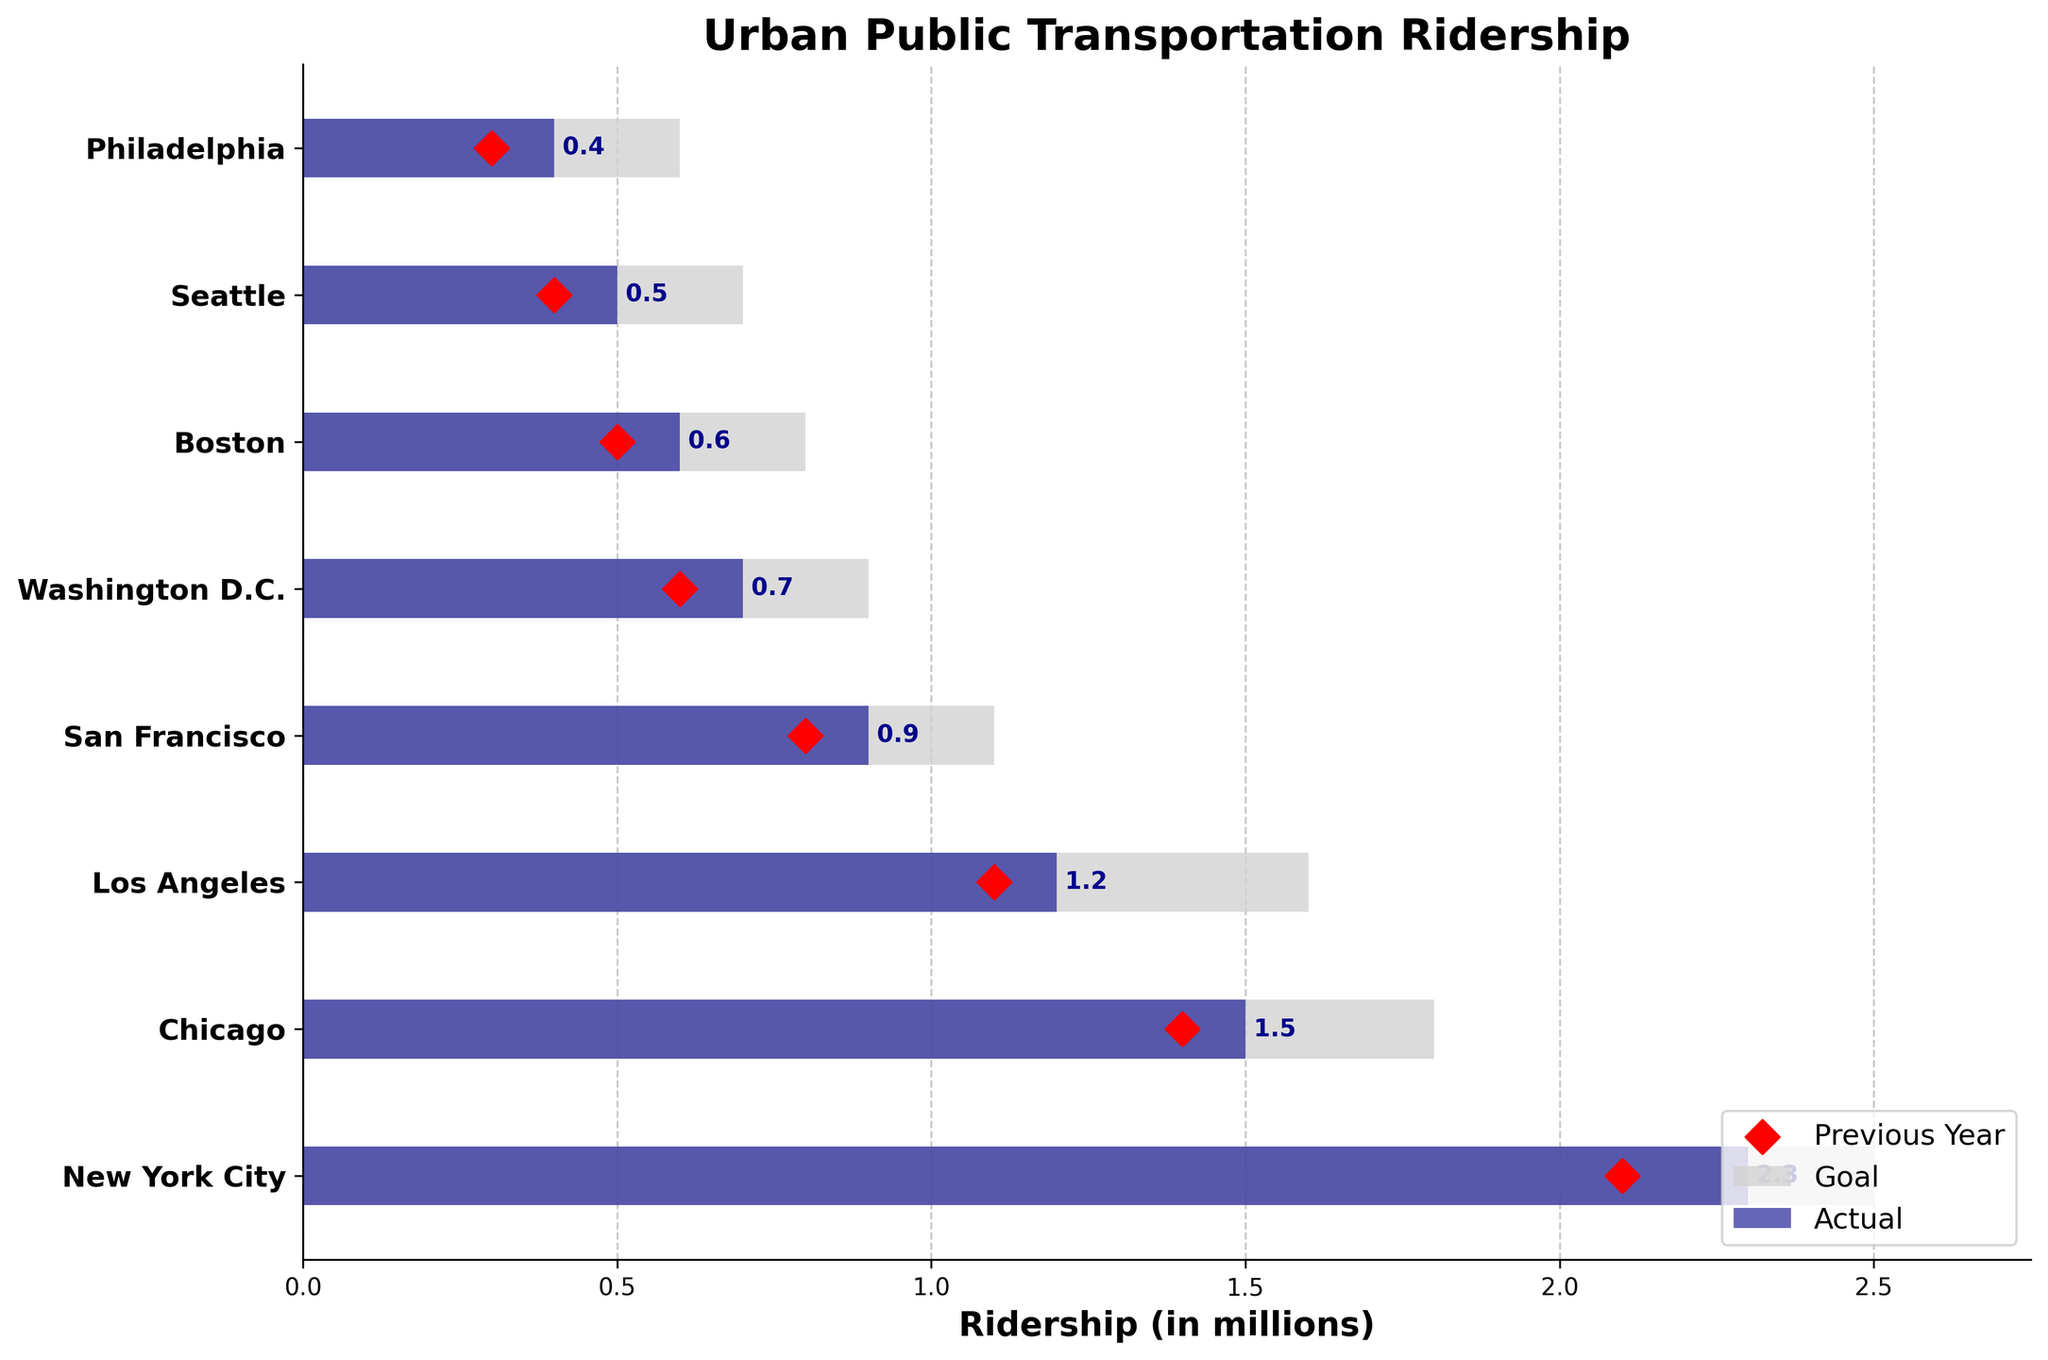What is the title of the chart? The title is located at the top of the chart and describes its content.
Answer: Urban Public Transportation Ridership Which city has the highest actual ridership? The highest actual ridership is represented by the tallest dark blue bar.
Answer: New York City How does Chicago's actual ridership compare to its goal ridership? Compare the dark blue bar (actual) and the light grey bar (goal) for Chicago.
Answer: 1.5 vs 1.8 million What is the average actual ridership across all cities? Sum the actual ridership for all cities (2.3+1.5+1.2+0.9+0.7+0.6+0.5+0.4) and divide by the number of cities (8).
Answer: 1.025 million How much did Los Angeles' actual ridership increase from the previous year? Subtract the previous year ridership (1.1 million) from the actual ridership (1.2 million) for Los Angeles.
Answer: 0.1 million Which city is closest to achieving its goal ridership? Determine the city with the smallest difference between actual and goal ridership by comparing the lengths of the dark blue and light grey bars.
Answer: New York City (0.2 million difference) List all cities where the actual ridership is less than the previous year's ridership. Identify cities where the dark blue bar is smaller than the red marker.
Answer: None What is the total goal ridership for all cities combined? Sum the goal ridership for all cities (2.5+1.8+1.6+1.1+0.9+0.8+0.7+0.6).
Answer: 10 million Which city has the smallest difference between actual and previous year ridership? Compare the gaps between the dark blue bars and red markers for all cities.
Answer: New York City (0.2 million difference) What is the maximum actual ridership represented in the chart? Identify the highest value on the X-axis that corresponds to the endpoints of the dark blue bars.
Answer: 2.3 million 